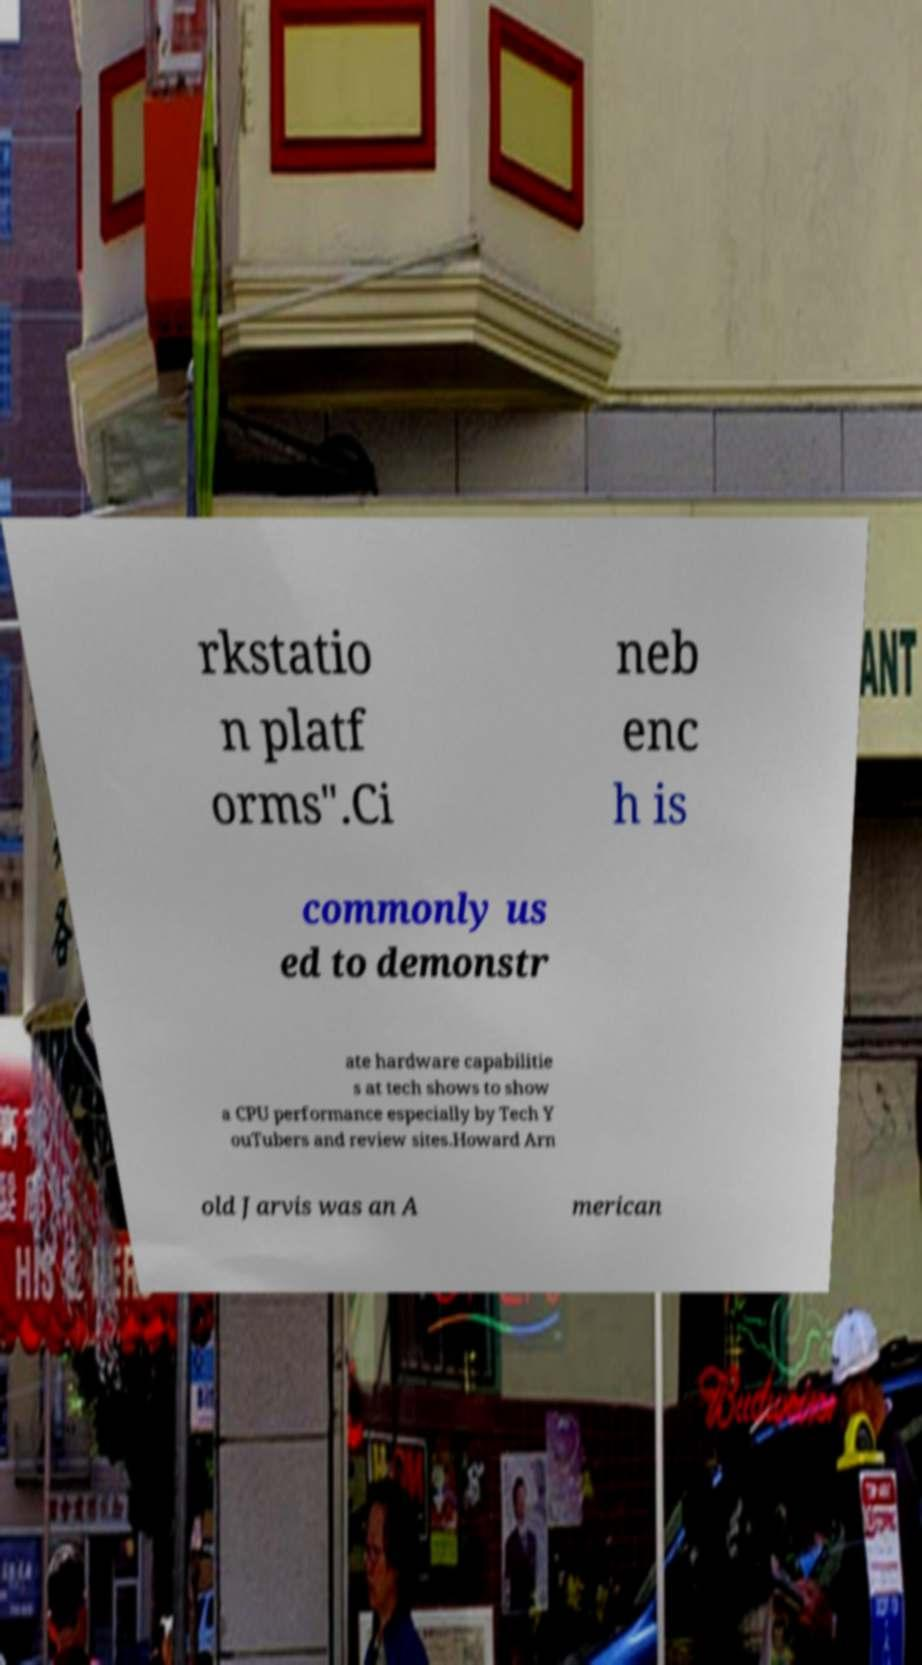Can you read and provide the text displayed in the image?This photo seems to have some interesting text. Can you extract and type it out for me? rkstatio n platf orms".Ci neb enc h is commonly us ed to demonstr ate hardware capabilitie s at tech shows to show a CPU performance especially by Tech Y ouTubers and review sites.Howard Arn old Jarvis was an A merican 